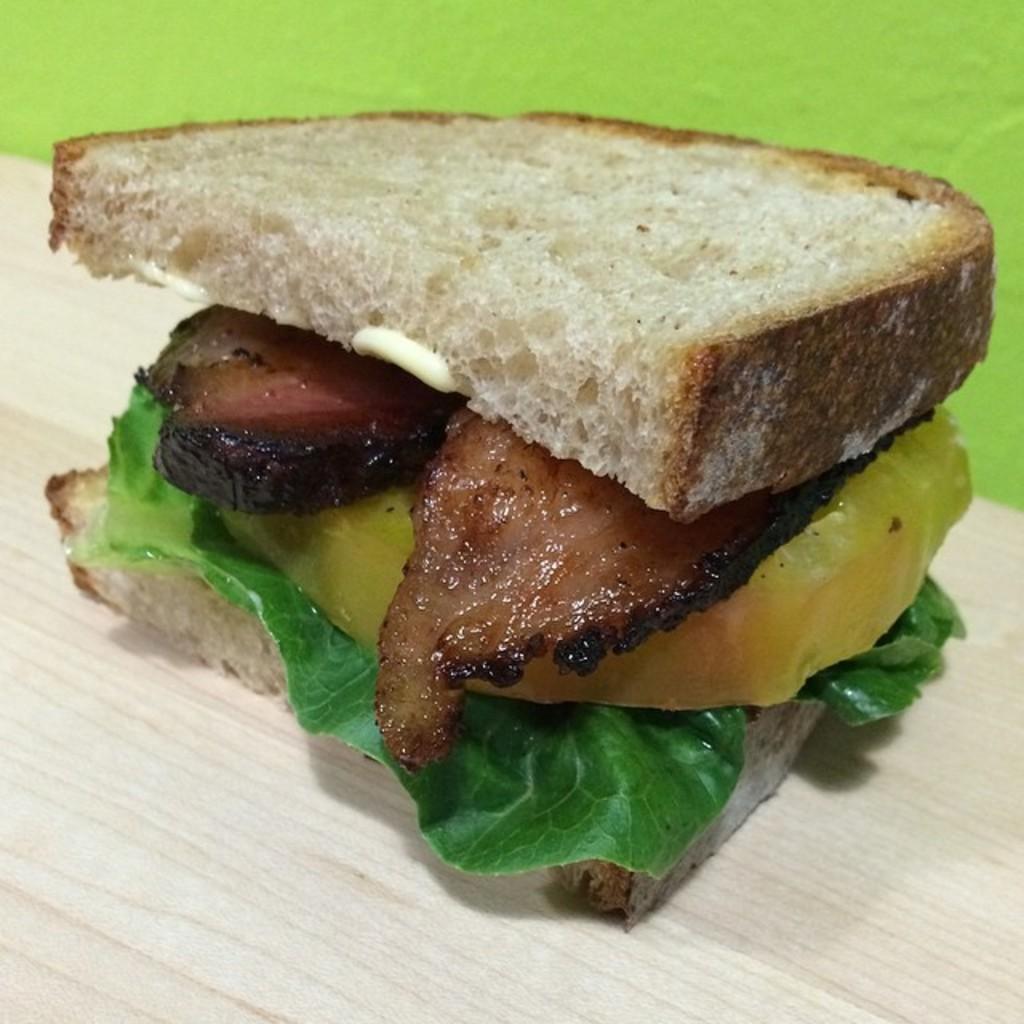Describe this image in one or two sentences. In this picture I can see food item on a wooden surface. 